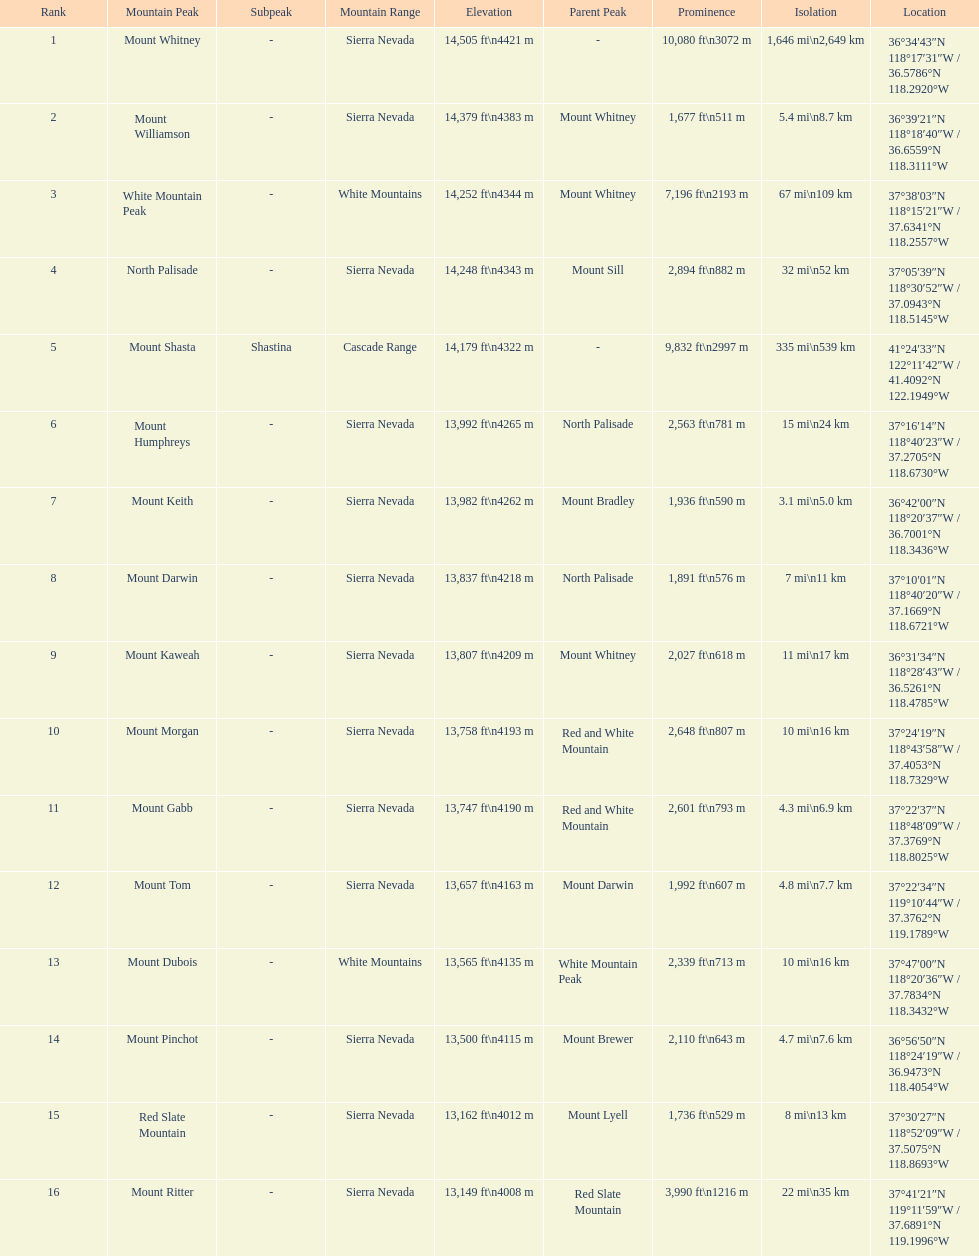What is the tallest peak in the sierra nevadas? Mount Whitney. 